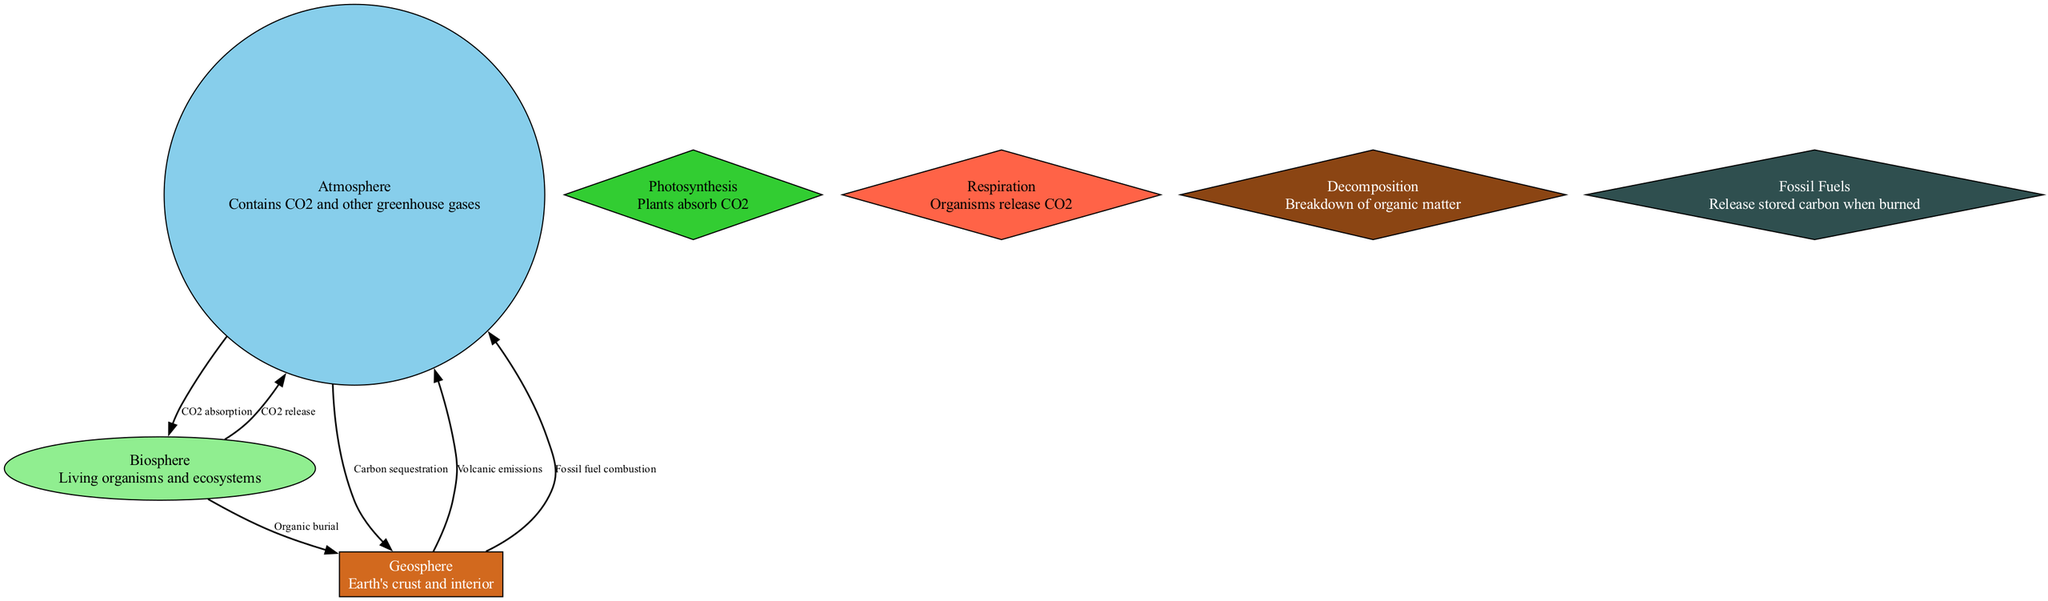What is the label of the node that represents living organisms? The node representing living organisms is labeled "Biosphere." Upon inspecting the diagram, we see a node specifically dedicated to this concept, described as "Living organisms and ecosystems."
Answer: Biosphere How many nodes are in the diagram? By counting all distinct elements in the diagram, it includes seven nodes in total: Atmosphere, Biosphere, Geosphere, Photosynthesis, Respiration, Decomposition, and Fossil Fuels.
Answer: Seven What is the relationship labeled between the atmosphere and the geosphere? The directed edge from the atmosphere to the geosphere represents "Carbon sequestration," which means carbon is stored in the geosphere. This connection indicates the specific interaction mentioned in the diagram.
Answer: Carbon sequestration Which process leads to CO2 being absorbed by plants? The process that leads to CO2 absorption by plants is labeled "Photosynthesis." In the diagram, this node illustrates the connection showing how plants take in CO2 from the atmosphere.
Answer: Photosynthesis Which process transitions organic matter from the biosphere to the geosphere? The process labeled "Organic burial" shows how organic matter moves from the biosphere to the geosphere, indicating that dead organic material is deposited and stored within the Earth's crust over time.
Answer: Organic burial What gas is released by organisms during respiration? The gas released during respiration is CO2. When looking at the respiration node, it clearly states that organisms release CO2 back into the atmosphere, indicating the cyclical nature of this process.
Answer: CO2 What happens when fossil fuels are burned according to the diagram? When fossil fuels are burned, the relationship labeled "Release stored carbon when burned" indicates that it releases large amounts of CO2 back into the atmosphere, which affects climate change and the carbon cycle.
Answer: Release stored carbon when burned Which node is colored green in the diagram? The node that is colored green represents the "Biosphere," which indicates living ecosystems and highlights its importance in absorbing CO2 during photosynthesis.
Answer: Biosphere 